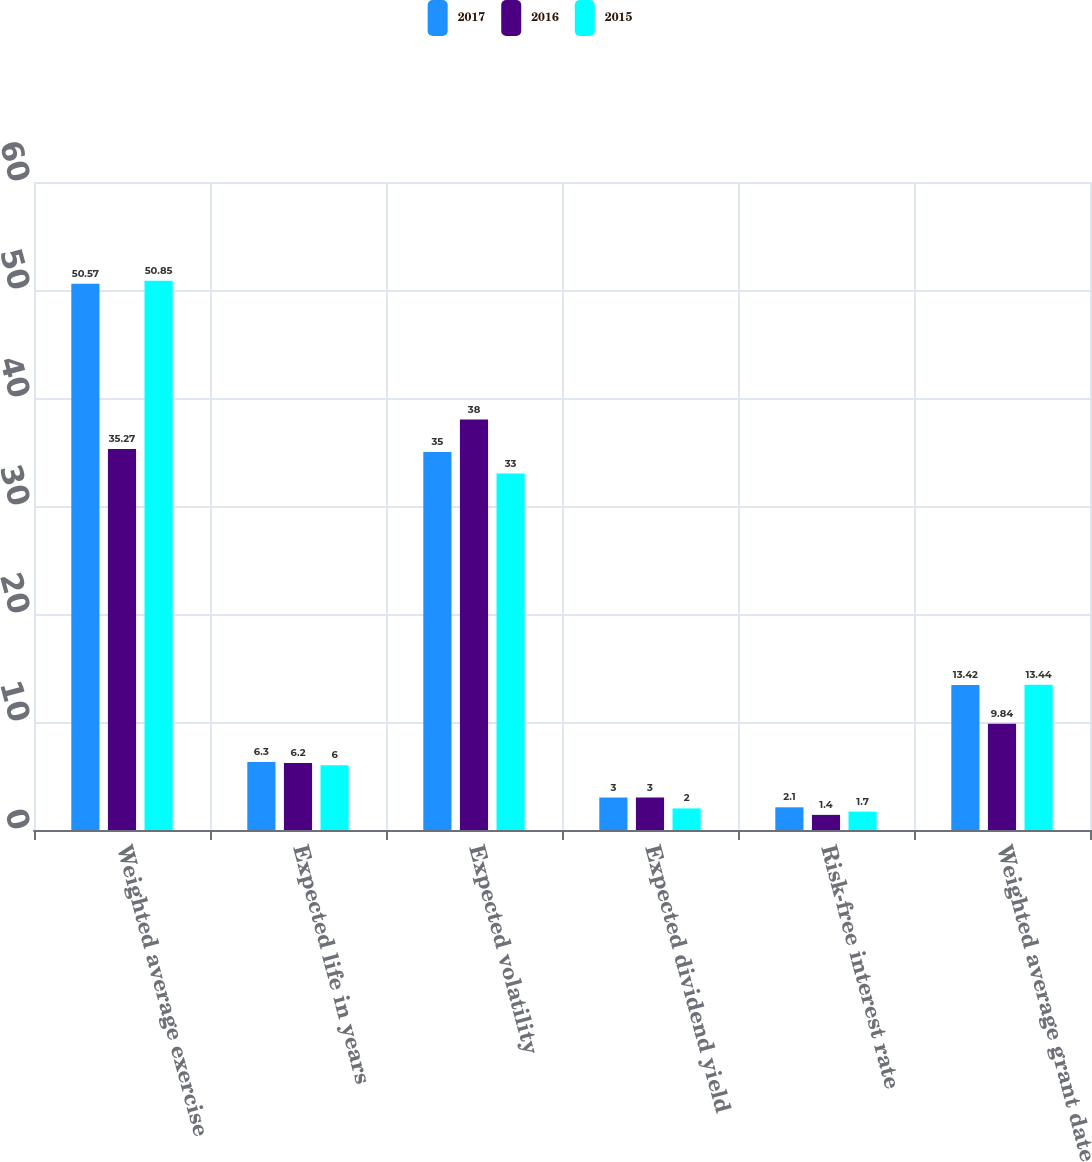<chart> <loc_0><loc_0><loc_500><loc_500><stacked_bar_chart><ecel><fcel>Weighted average exercise<fcel>Expected life in years<fcel>Expected volatility<fcel>Expected dividend yield<fcel>Risk-free interest rate<fcel>Weighted average grant date<nl><fcel>2017<fcel>50.57<fcel>6.3<fcel>35<fcel>3<fcel>2.1<fcel>13.42<nl><fcel>2016<fcel>35.27<fcel>6.2<fcel>38<fcel>3<fcel>1.4<fcel>9.84<nl><fcel>2015<fcel>50.85<fcel>6<fcel>33<fcel>2<fcel>1.7<fcel>13.44<nl></chart> 